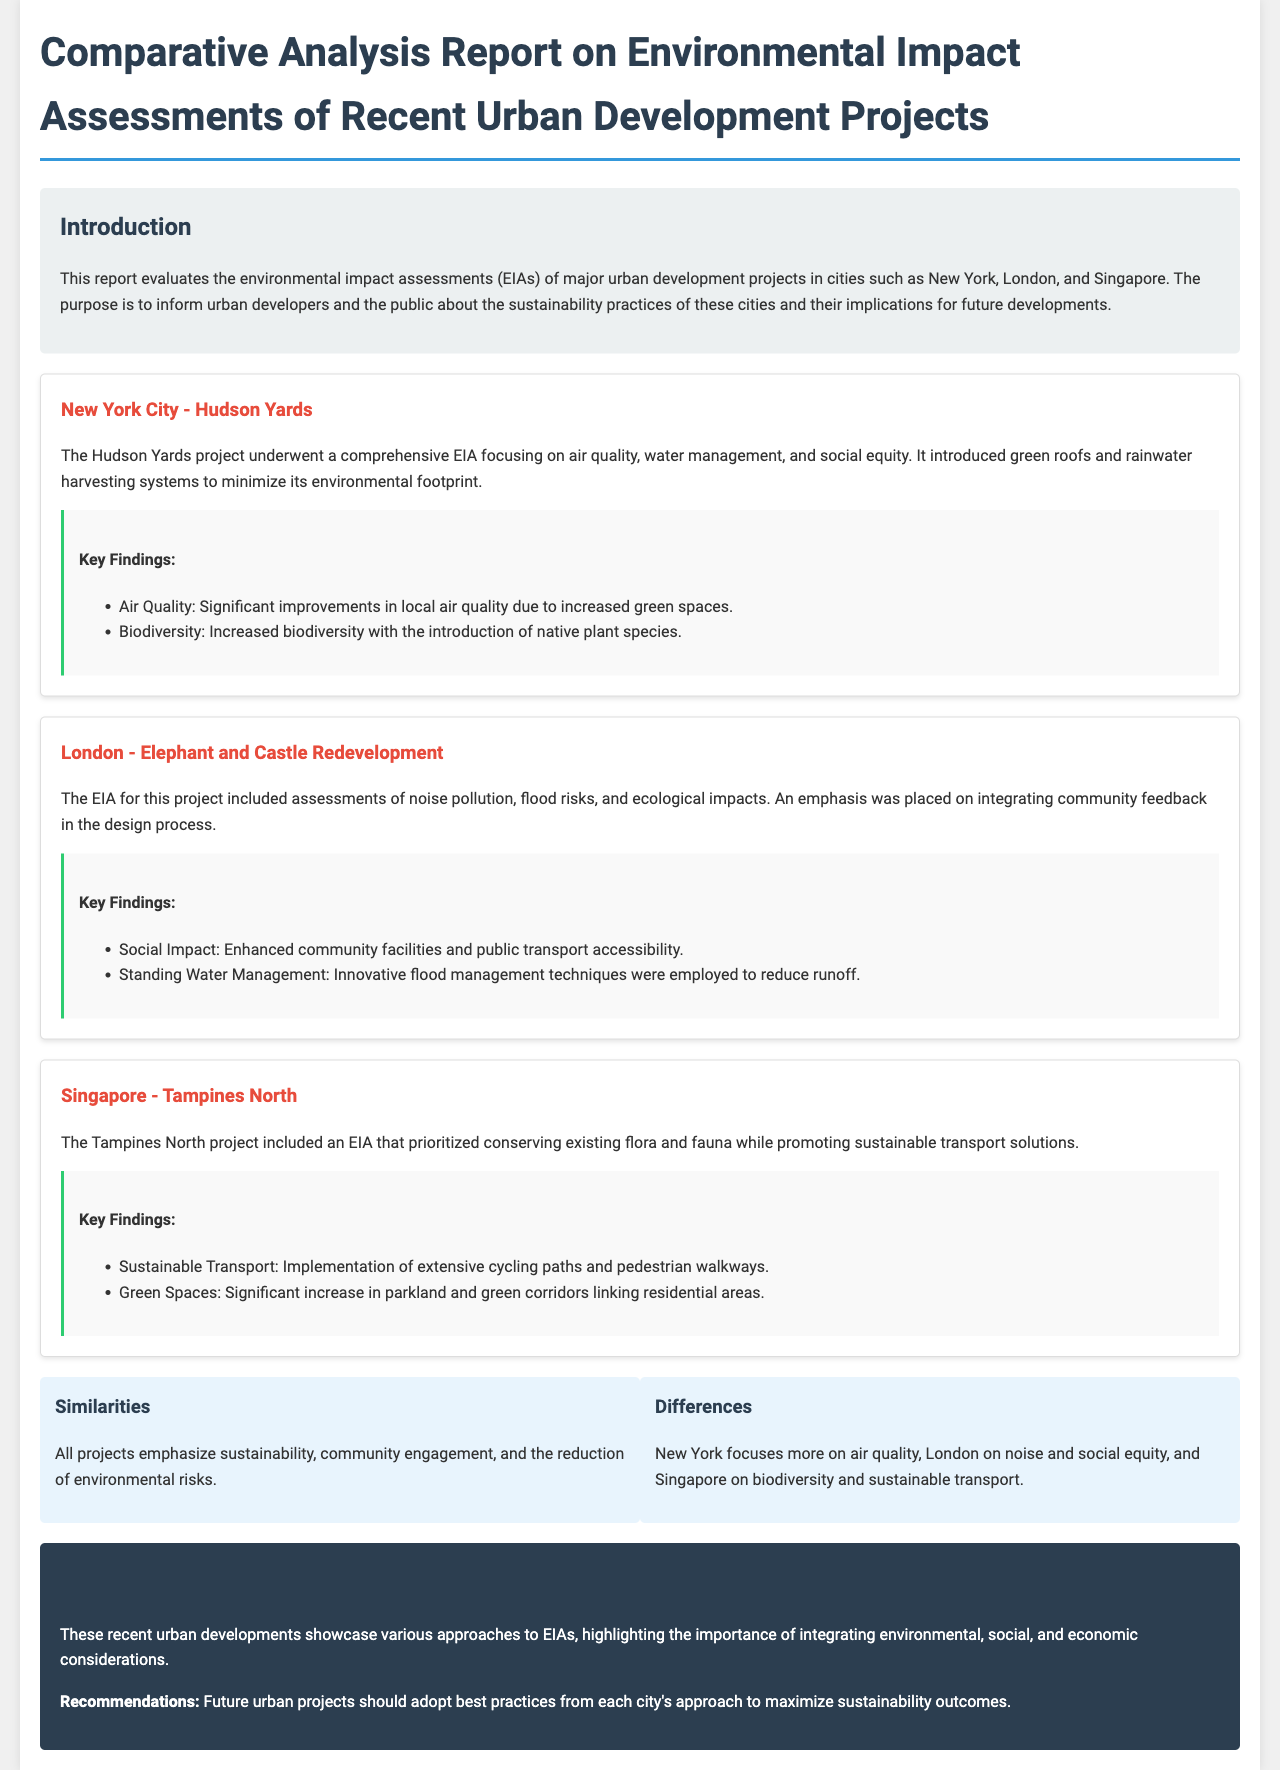what is the title of the report? The title of the report is found at the top of the document.
Answer: Comparative Analysis Report on Environmental Impact Assessments of Recent Urban Development Projects which city is associated with the Hudson Yards project? The document explicitly states which city is related to the Hudson Yards project.
Answer: New York City what was a key finding related to social impact in the Elephant and Castle Redevelopment? The document lists the key findings for each city project, including social impacts.
Answer: Enhanced community facilities and public transport accessibility how many key findings are noted for the Tampines North project? The number of bulleted key findings for each project can be counted in the document.
Answer: Two what environmental focus does Singapore's Tampines North project prioritize? The primary environmental focus is noted in the description of the project.
Answer: Conserving existing flora and fauna what is a similarity among all the projects discussed? The document outlines common themes among the projects.
Answer: Sustainability which project's EIA emphasized community feedback? The document details which project focused on community involvement in its EIA.
Answer: Elephant and Castle Redevelopment what is a recommended best practice mentioned in the conclusion? Recommendations provided in the conclusion summarize the best practices discussed.
Answer: Adopt best practices from each city's approach 